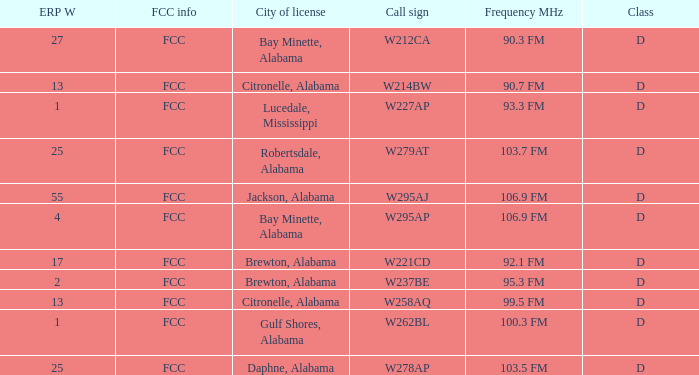Name the frequence MHz for ERP W of 55 106.9 FM. 